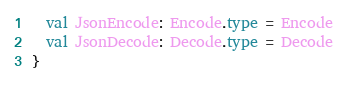Convert code to text. <code><loc_0><loc_0><loc_500><loc_500><_Scala_>  val JsonEncode: Encode.type = Encode
  val JsonDecode: Decode.type = Decode
}
</code> 